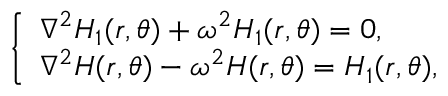Convert formula to latex. <formula><loc_0><loc_0><loc_500><loc_500>\left \{ \begin{array} { l l } { \nabla ^ { 2 } H _ { 1 } ( r , \theta ) + \omega ^ { 2 } H _ { 1 } ( r , \theta ) = 0 , } \\ { \nabla ^ { 2 } H ( r , \theta ) - \omega ^ { 2 } H ( r , \theta ) = H _ { 1 } ( r , \theta ) , } \end{array}</formula> 